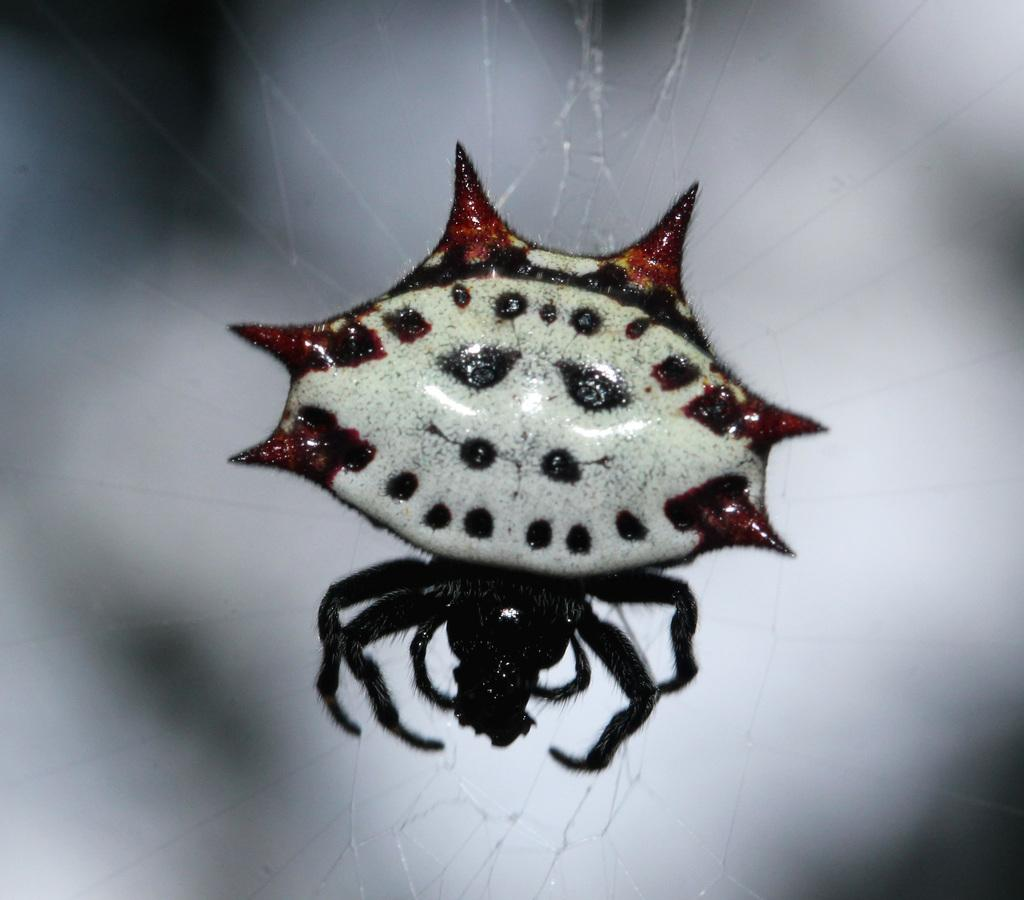What is the main subject of the image? The main subject of the image is a spider. Where is the spider located in the image? The spider is on a web. What type of business does the father in the image own? There is no father or business present in the image; it only features a spider on a web. 